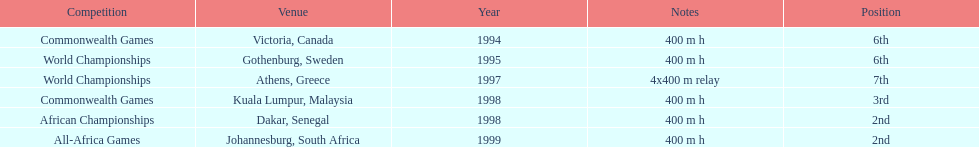In what year did ken harnden engage in over one competition? 1998. 